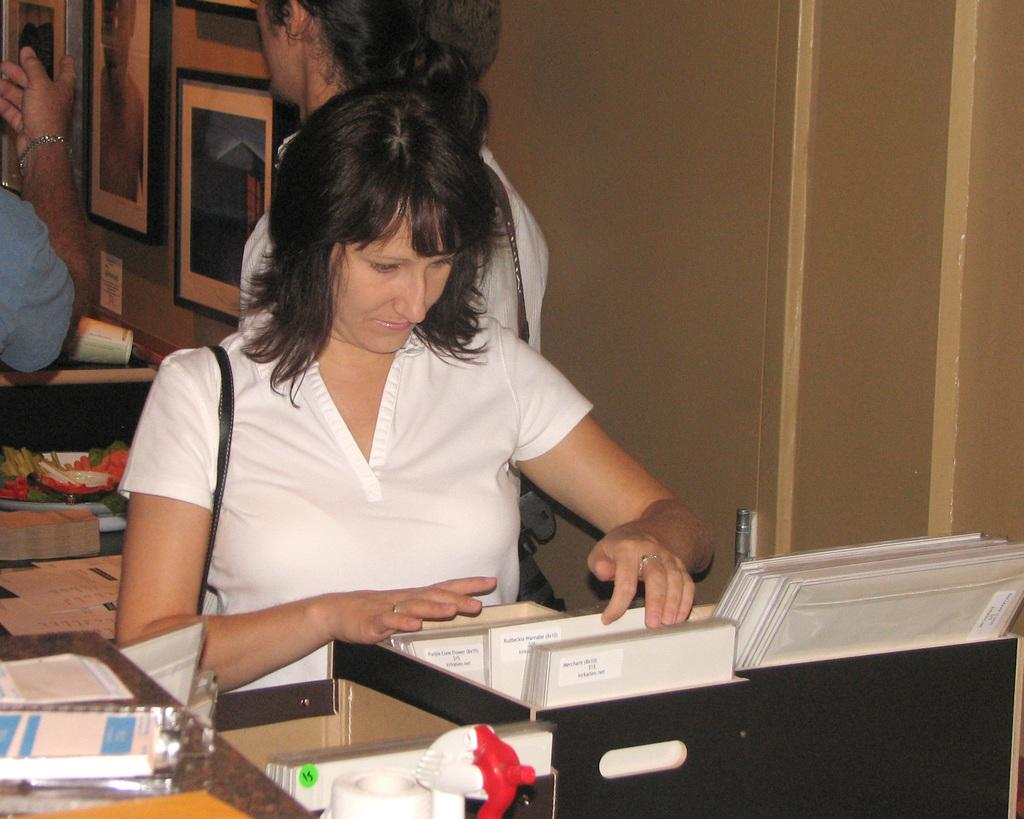What is happening in the image? There are people standing in the image. What can be seen on the wall in the image? There are photo frames on the wall. What is on the table in the image? There are papers and books on the table. What is inside the box in the image? There are files in a box. What accessory is the woman wearing? The woman is wearing a handbag. What type of punishment is being administered in the image? There is no punishment being administered in the image; it simply shows people standing and various objects. 